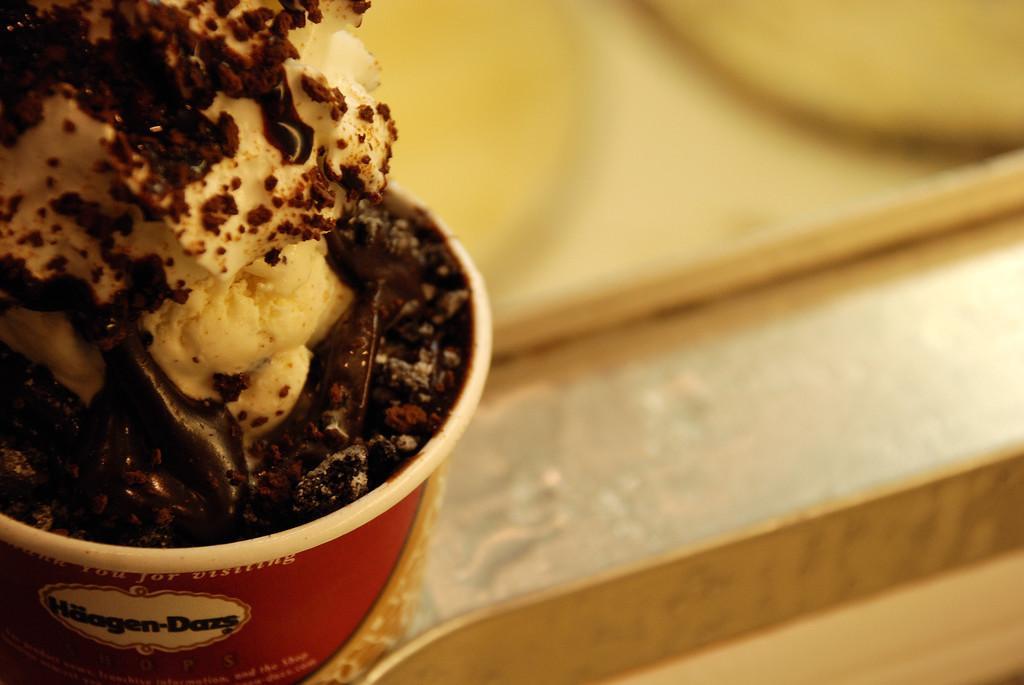Can you describe this image briefly? On the left side of the image we can see an ice cream and there are trays. 